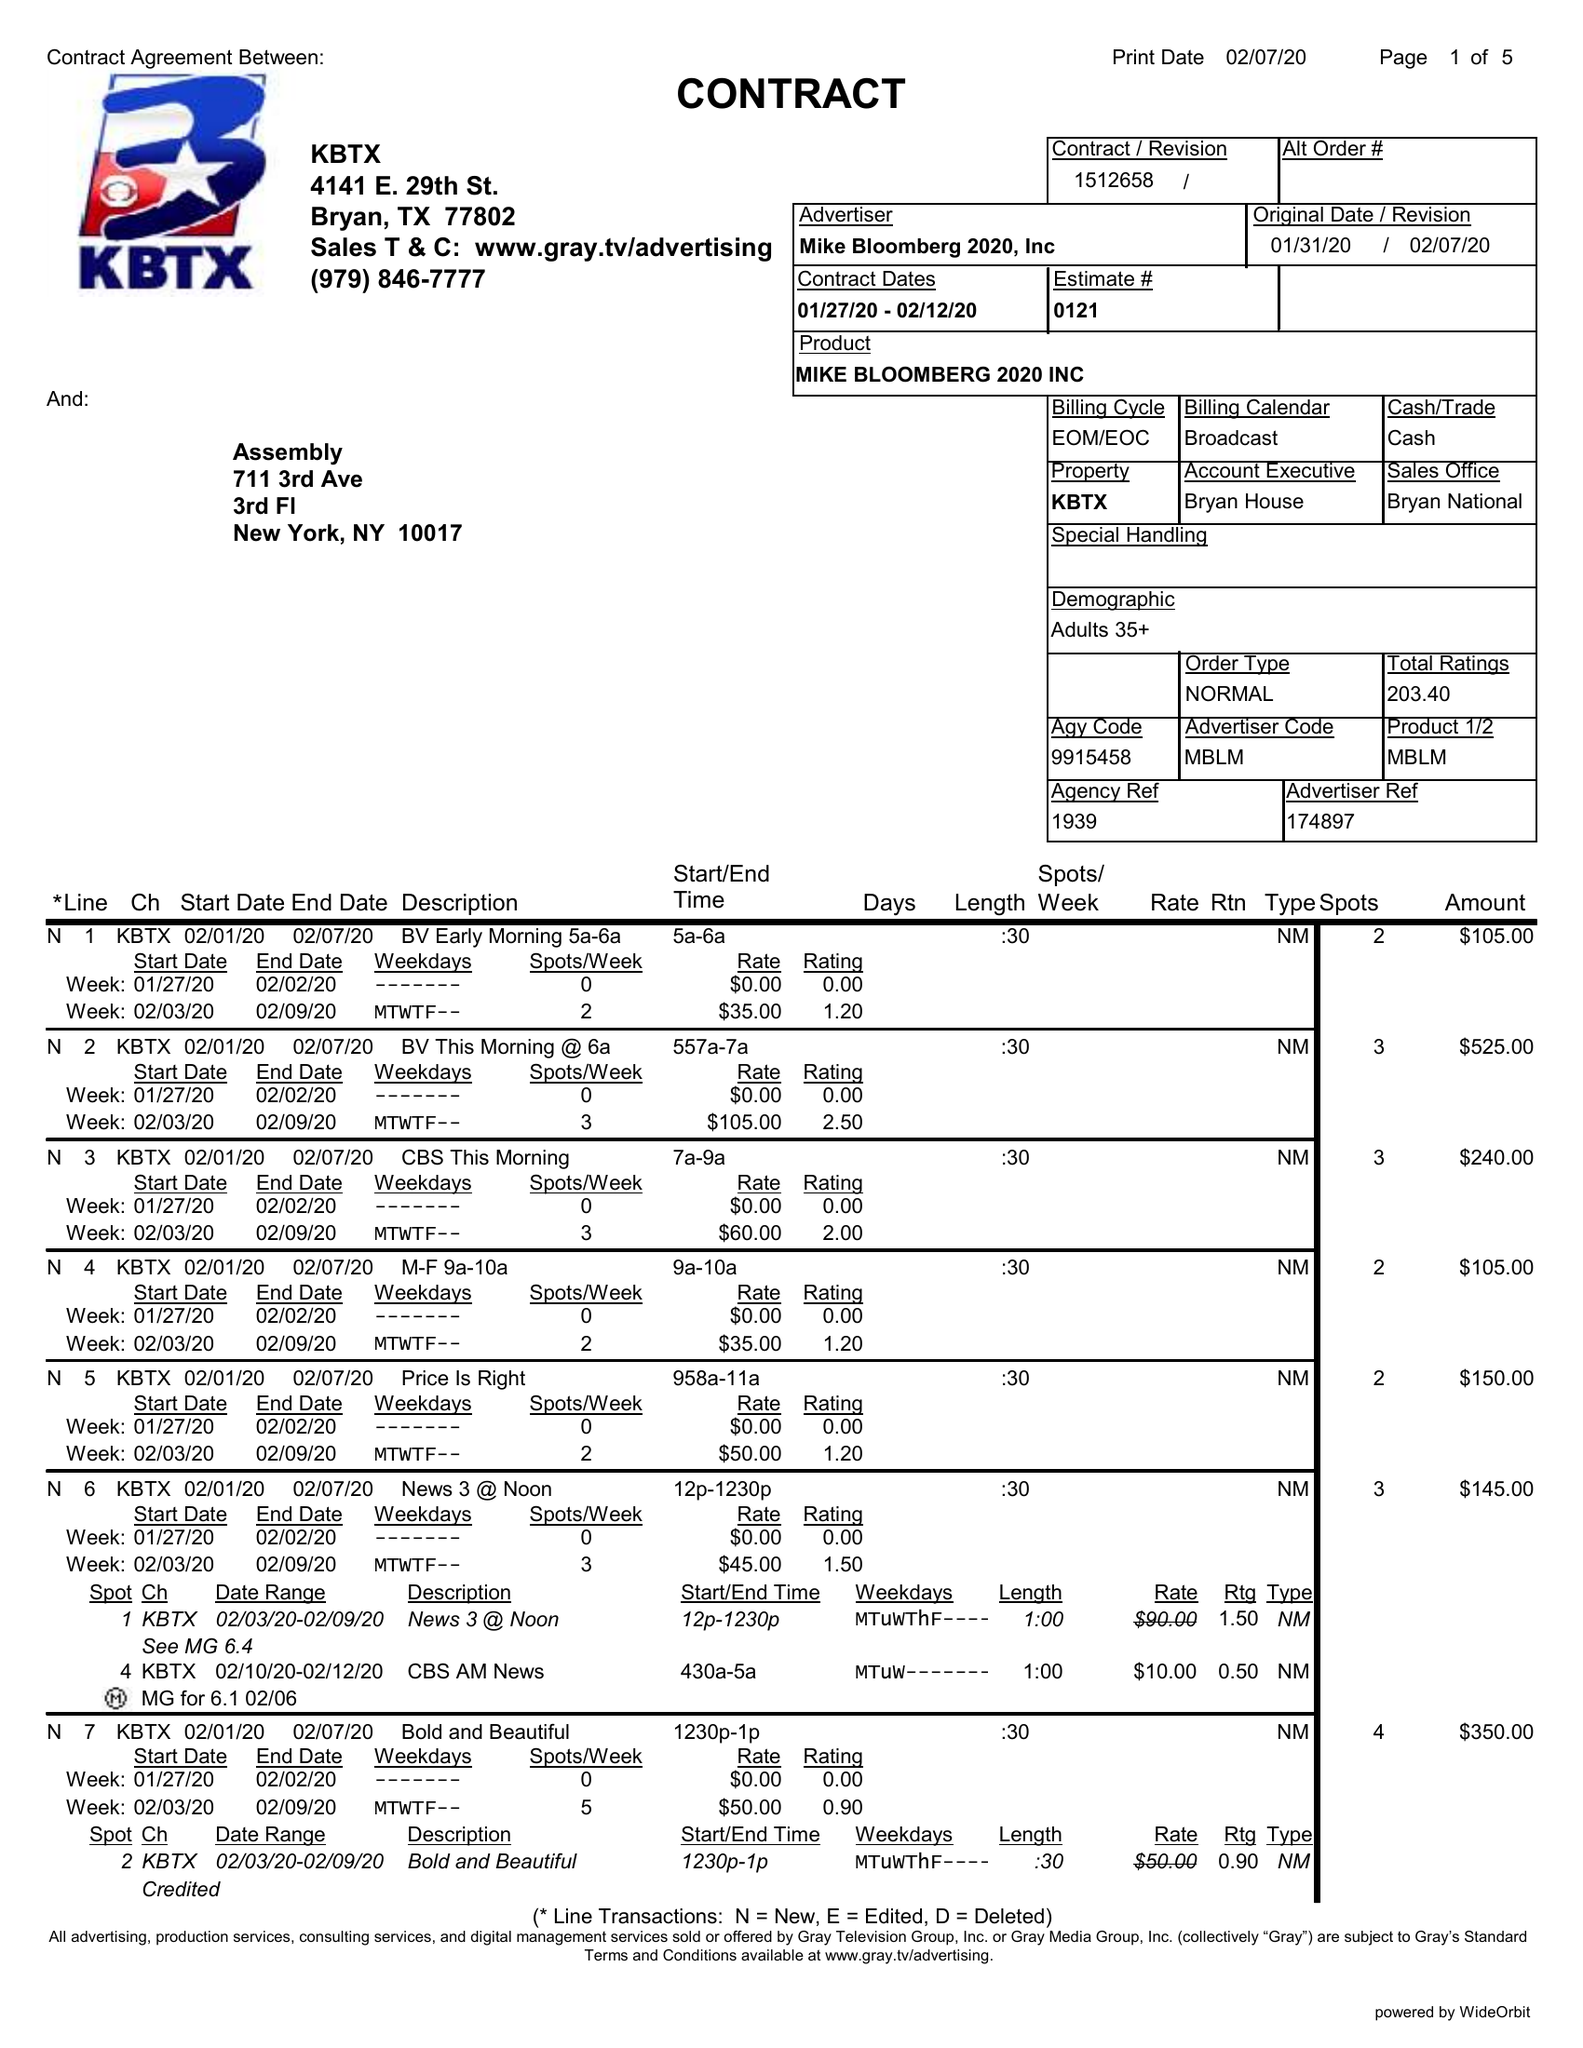What is the value for the contract_num?
Answer the question using a single word or phrase. 1512658 